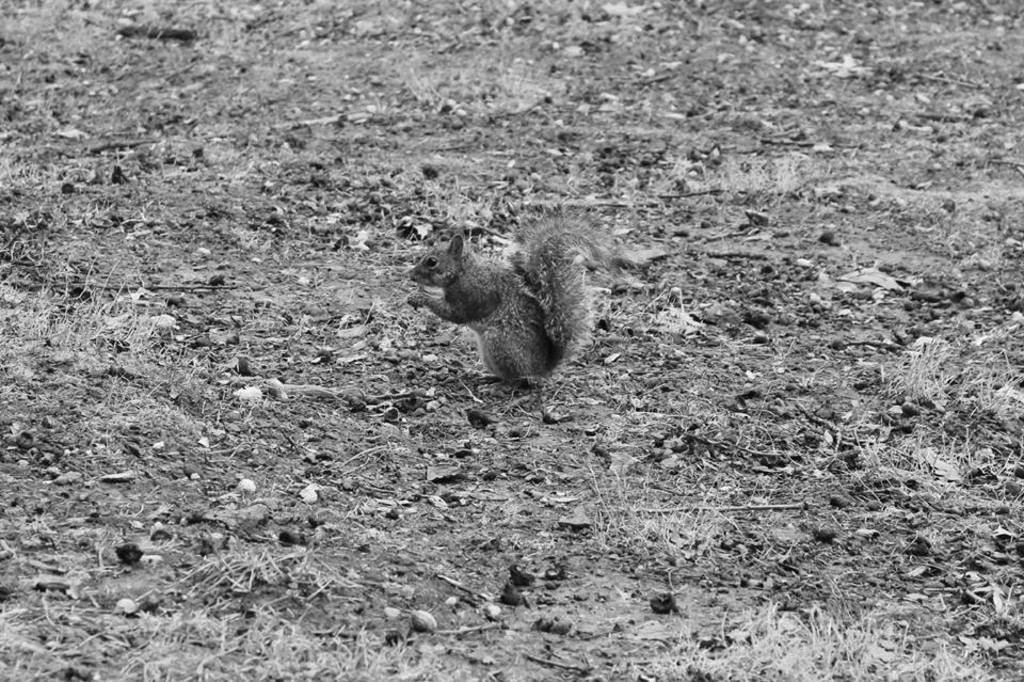What is the color scheme of the image? The image is black and white. What type of animal can be seen in the image? There is a squirrel in the image. What type of vegetation is on the ground in the image? There is grass on the ground in the image. What else can be found on the ground in the image? There are other items on the ground in the image. What is the squirrel's belief about the quiet land in the image? There is no mention of land or quietness in the image, and we cannot determine the squirrel's beliefs based on the provided facts. 